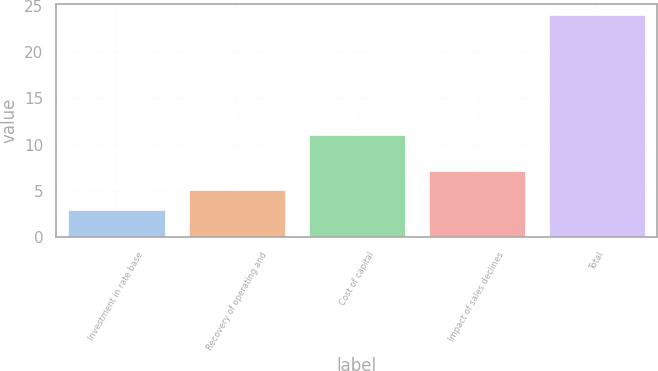Convert chart to OTSL. <chart><loc_0><loc_0><loc_500><loc_500><bar_chart><fcel>Investment in rate base<fcel>Recovery of operating and<fcel>Cost of capital<fcel>Impact of sales declines<fcel>Total<nl><fcel>3<fcel>5.1<fcel>11<fcel>7.2<fcel>24<nl></chart> 